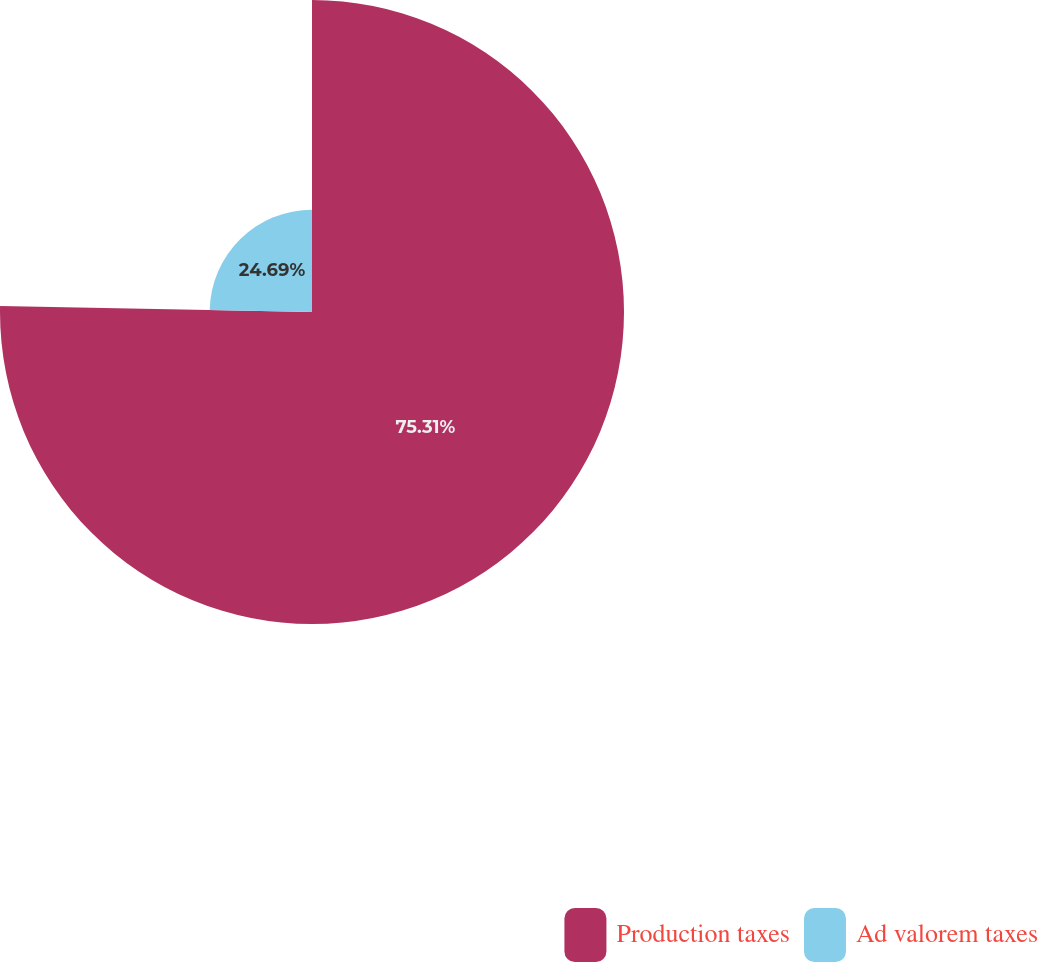Convert chart to OTSL. <chart><loc_0><loc_0><loc_500><loc_500><pie_chart><fcel>Production taxes<fcel>Ad valorem taxes<nl><fcel>75.31%<fcel>24.69%<nl></chart> 